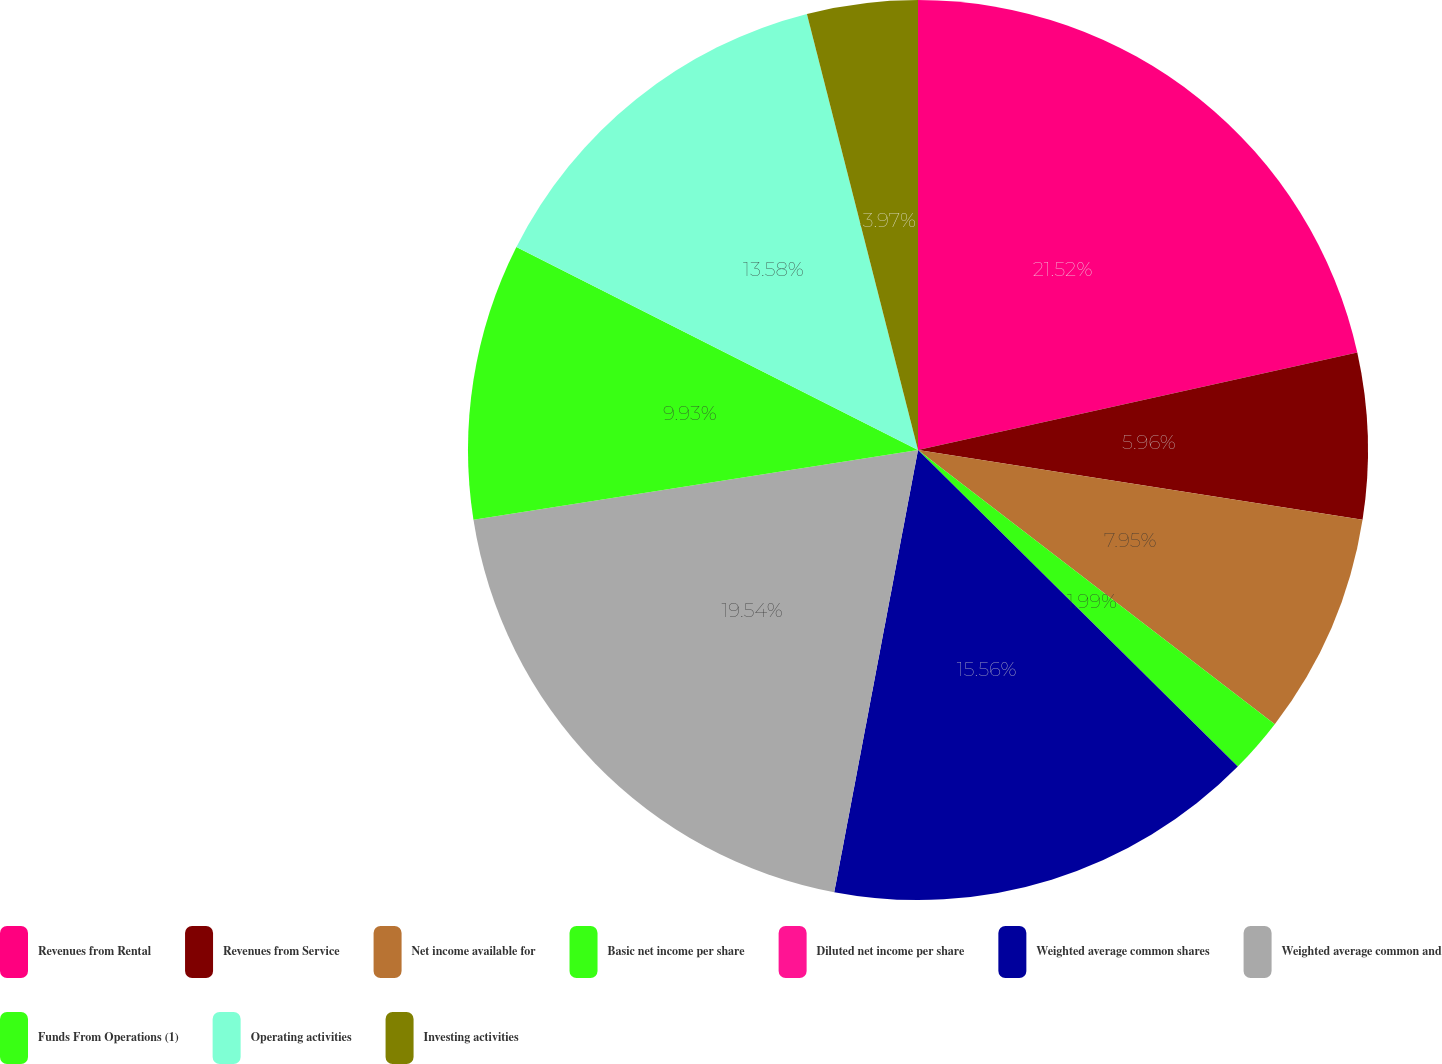Convert chart. <chart><loc_0><loc_0><loc_500><loc_500><pie_chart><fcel>Revenues from Rental<fcel>Revenues from Service<fcel>Net income available for<fcel>Basic net income per share<fcel>Diluted net income per share<fcel>Weighted average common shares<fcel>Weighted average common and<fcel>Funds From Operations (1)<fcel>Operating activities<fcel>Investing activities<nl><fcel>21.52%<fcel>5.96%<fcel>7.95%<fcel>1.99%<fcel>0.0%<fcel>15.56%<fcel>19.54%<fcel>9.93%<fcel>13.58%<fcel>3.97%<nl></chart> 